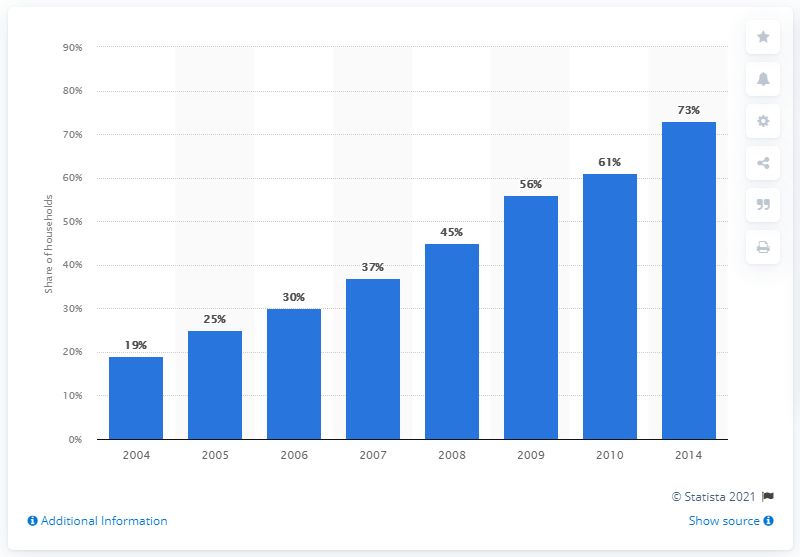List a handful of essential elements in this visual. In 2014, about 73% of households in Poland used either a desktop or portable computer to access the internet. 